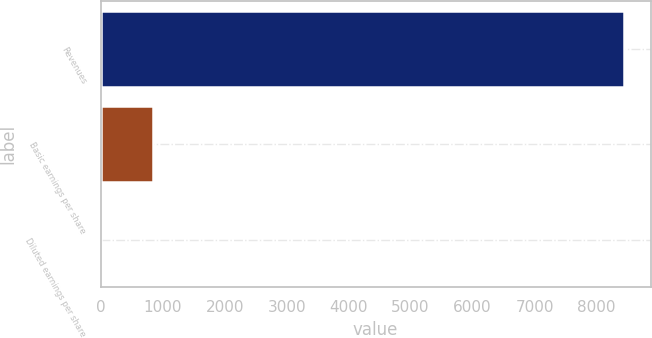Convert chart. <chart><loc_0><loc_0><loc_500><loc_500><bar_chart><fcel>Revenues<fcel>Basic earnings per share<fcel>Diluted earnings per share<nl><fcel>8450<fcel>845.82<fcel>0.91<nl></chart> 